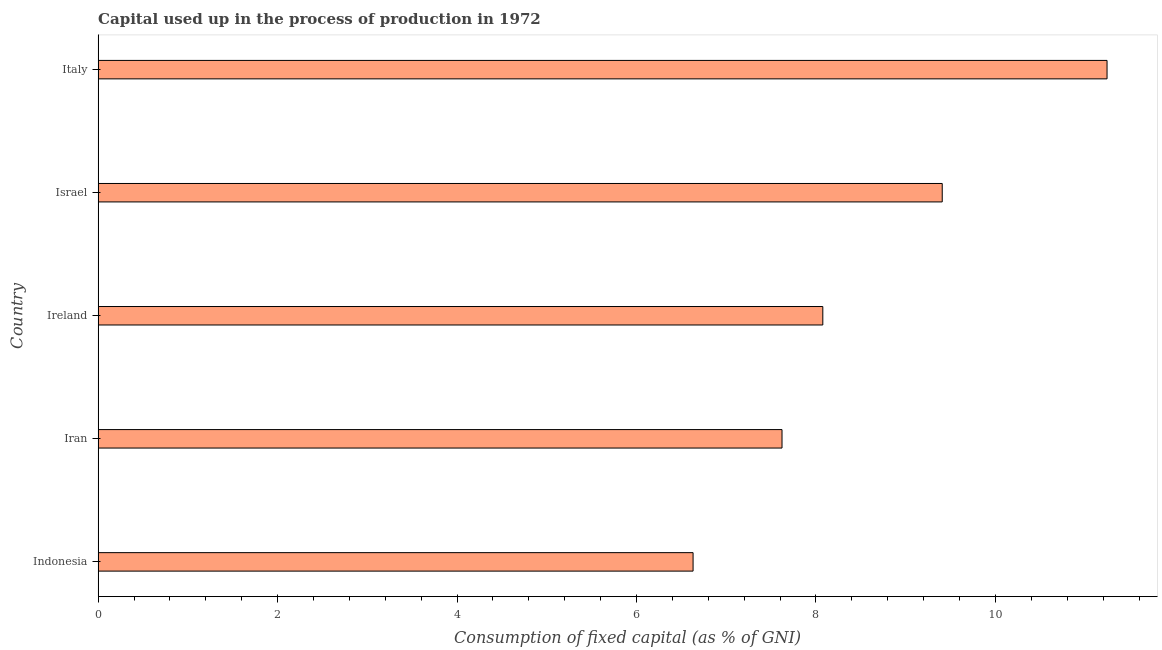Does the graph contain any zero values?
Ensure brevity in your answer.  No. What is the title of the graph?
Keep it short and to the point. Capital used up in the process of production in 1972. What is the label or title of the X-axis?
Ensure brevity in your answer.  Consumption of fixed capital (as % of GNI). What is the label or title of the Y-axis?
Provide a succinct answer. Country. What is the consumption of fixed capital in Iran?
Give a very brief answer. 7.62. Across all countries, what is the maximum consumption of fixed capital?
Your response must be concise. 11.24. Across all countries, what is the minimum consumption of fixed capital?
Make the answer very short. 6.63. In which country was the consumption of fixed capital maximum?
Your response must be concise. Italy. What is the sum of the consumption of fixed capital?
Your answer should be compact. 42.98. What is the difference between the consumption of fixed capital in Indonesia and Ireland?
Your response must be concise. -1.45. What is the average consumption of fixed capital per country?
Offer a terse response. 8.6. What is the median consumption of fixed capital?
Offer a very short reply. 8.08. In how many countries, is the consumption of fixed capital greater than 7.2 %?
Offer a very short reply. 4. What is the ratio of the consumption of fixed capital in Iran to that in Italy?
Make the answer very short. 0.68. Is the difference between the consumption of fixed capital in Iran and Israel greater than the difference between any two countries?
Offer a very short reply. No. What is the difference between the highest and the second highest consumption of fixed capital?
Make the answer very short. 1.84. What is the difference between the highest and the lowest consumption of fixed capital?
Your answer should be compact. 4.61. How many bars are there?
Ensure brevity in your answer.  5. Are all the bars in the graph horizontal?
Your response must be concise. Yes. What is the Consumption of fixed capital (as % of GNI) of Indonesia?
Keep it short and to the point. 6.63. What is the Consumption of fixed capital (as % of GNI) of Iran?
Provide a short and direct response. 7.62. What is the Consumption of fixed capital (as % of GNI) in Ireland?
Offer a very short reply. 8.08. What is the Consumption of fixed capital (as % of GNI) in Israel?
Provide a succinct answer. 9.41. What is the Consumption of fixed capital (as % of GNI) of Italy?
Your answer should be very brief. 11.24. What is the difference between the Consumption of fixed capital (as % of GNI) in Indonesia and Iran?
Provide a short and direct response. -0.99. What is the difference between the Consumption of fixed capital (as % of GNI) in Indonesia and Ireland?
Provide a short and direct response. -1.45. What is the difference between the Consumption of fixed capital (as % of GNI) in Indonesia and Israel?
Your answer should be compact. -2.78. What is the difference between the Consumption of fixed capital (as % of GNI) in Indonesia and Italy?
Your response must be concise. -4.61. What is the difference between the Consumption of fixed capital (as % of GNI) in Iran and Ireland?
Your answer should be compact. -0.45. What is the difference between the Consumption of fixed capital (as % of GNI) in Iran and Israel?
Make the answer very short. -1.79. What is the difference between the Consumption of fixed capital (as % of GNI) in Iran and Italy?
Give a very brief answer. -3.62. What is the difference between the Consumption of fixed capital (as % of GNI) in Ireland and Israel?
Offer a terse response. -1.33. What is the difference between the Consumption of fixed capital (as % of GNI) in Ireland and Italy?
Your answer should be very brief. -3.17. What is the difference between the Consumption of fixed capital (as % of GNI) in Israel and Italy?
Provide a succinct answer. -1.84. What is the ratio of the Consumption of fixed capital (as % of GNI) in Indonesia to that in Iran?
Your answer should be very brief. 0.87. What is the ratio of the Consumption of fixed capital (as % of GNI) in Indonesia to that in Ireland?
Ensure brevity in your answer.  0.82. What is the ratio of the Consumption of fixed capital (as % of GNI) in Indonesia to that in Israel?
Offer a very short reply. 0.7. What is the ratio of the Consumption of fixed capital (as % of GNI) in Indonesia to that in Italy?
Give a very brief answer. 0.59. What is the ratio of the Consumption of fixed capital (as % of GNI) in Iran to that in Ireland?
Give a very brief answer. 0.94. What is the ratio of the Consumption of fixed capital (as % of GNI) in Iran to that in Israel?
Ensure brevity in your answer.  0.81. What is the ratio of the Consumption of fixed capital (as % of GNI) in Iran to that in Italy?
Ensure brevity in your answer.  0.68. What is the ratio of the Consumption of fixed capital (as % of GNI) in Ireland to that in Israel?
Your response must be concise. 0.86. What is the ratio of the Consumption of fixed capital (as % of GNI) in Ireland to that in Italy?
Your answer should be compact. 0.72. What is the ratio of the Consumption of fixed capital (as % of GNI) in Israel to that in Italy?
Provide a succinct answer. 0.84. 